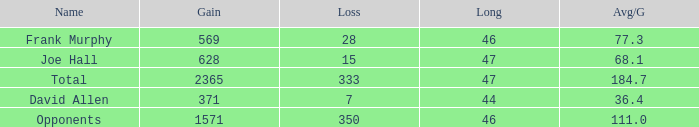Which Avg/G is the lowest one that has a Long smaller than 47, and a Name of frank murphy, and a Gain smaller than 569? None. 